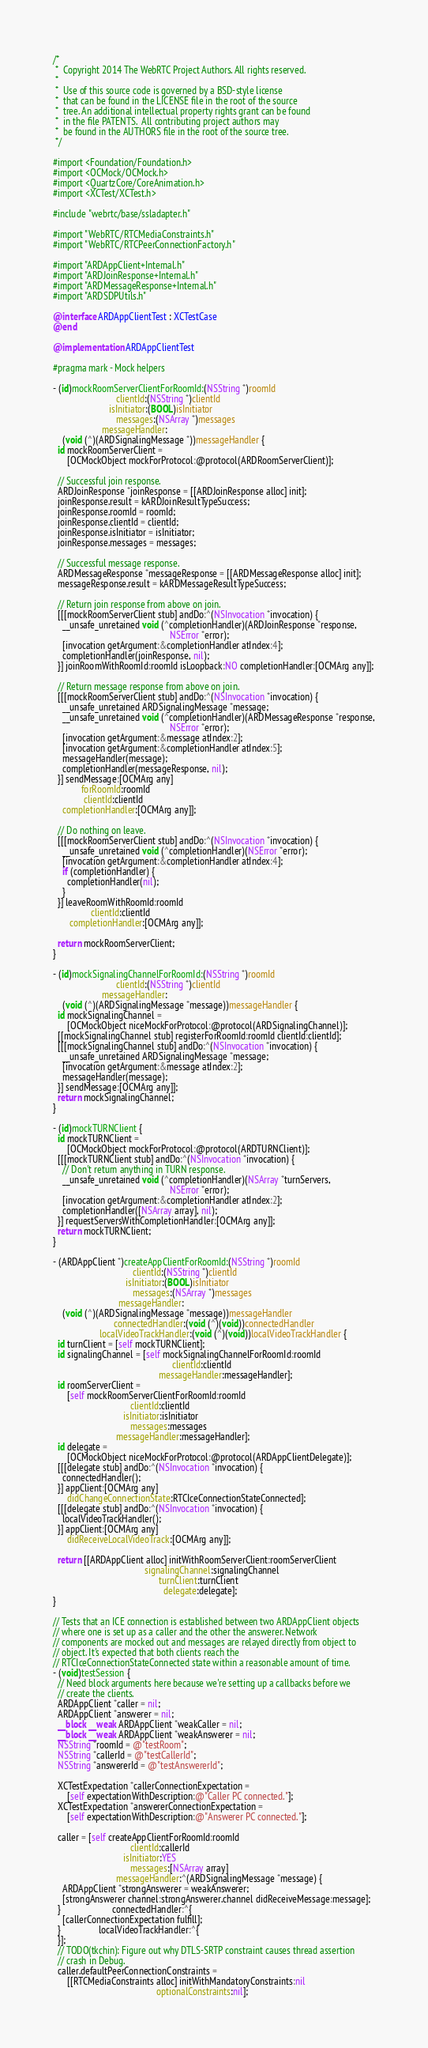Convert code to text. <code><loc_0><loc_0><loc_500><loc_500><_ObjectiveC_>/*
 *  Copyright 2014 The WebRTC Project Authors. All rights reserved.
 *
 *  Use of this source code is governed by a BSD-style license
 *  that can be found in the LICENSE file in the root of the source
 *  tree. An additional intellectual property rights grant can be found
 *  in the file PATENTS.  All contributing project authors may
 *  be found in the AUTHORS file in the root of the source tree.
 */

#import <Foundation/Foundation.h>
#import <OCMock/OCMock.h>
#import <QuartzCore/CoreAnimation.h>
#import <XCTest/XCTest.h>

#include "webrtc/base/ssladapter.h"

#import "WebRTC/RTCMediaConstraints.h"
#import "WebRTC/RTCPeerConnectionFactory.h"

#import "ARDAppClient+Internal.h"
#import "ARDJoinResponse+Internal.h"
#import "ARDMessageResponse+Internal.h"
#import "ARDSDPUtils.h"

@interface ARDAppClientTest : XCTestCase
@end

@implementation ARDAppClientTest

#pragma mark - Mock helpers

- (id)mockRoomServerClientForRoomId:(NSString *)roomId
                           clientId:(NSString *)clientId
                        isInitiator:(BOOL)isInitiator
                           messages:(NSArray *)messages
                     messageHandler:
    (void (^)(ARDSignalingMessage *))messageHandler {
  id mockRoomServerClient =
      [OCMockObject mockForProtocol:@protocol(ARDRoomServerClient)];

  // Successful join response.
  ARDJoinResponse *joinResponse = [[ARDJoinResponse alloc] init];
  joinResponse.result = kARDJoinResultTypeSuccess;
  joinResponse.roomId = roomId;
  joinResponse.clientId = clientId;
  joinResponse.isInitiator = isInitiator;
  joinResponse.messages = messages;

  // Successful message response.
  ARDMessageResponse *messageResponse = [[ARDMessageResponse alloc] init];
  messageResponse.result = kARDMessageResultTypeSuccess;

  // Return join response from above on join.
  [[[mockRoomServerClient stub] andDo:^(NSInvocation *invocation) {
    __unsafe_unretained void (^completionHandler)(ARDJoinResponse *response,
                                                  NSError *error);
    [invocation getArgument:&completionHandler atIndex:4];
    completionHandler(joinResponse, nil);
  }] joinRoomWithRoomId:roomId isLoopback:NO completionHandler:[OCMArg any]];

  // Return message response from above on join.
  [[[mockRoomServerClient stub] andDo:^(NSInvocation *invocation) {
    __unsafe_unretained ARDSignalingMessage *message;
    __unsafe_unretained void (^completionHandler)(ARDMessageResponse *response,
                                                  NSError *error);
    [invocation getArgument:&message atIndex:2];
    [invocation getArgument:&completionHandler atIndex:5];
    messageHandler(message);
    completionHandler(messageResponse, nil);
  }] sendMessage:[OCMArg any]
            forRoomId:roomId
             clientId:clientId
    completionHandler:[OCMArg any]];

  // Do nothing on leave.
  [[[mockRoomServerClient stub] andDo:^(NSInvocation *invocation) {
    __unsafe_unretained void (^completionHandler)(NSError *error);
    [invocation getArgument:&completionHandler atIndex:4];
    if (completionHandler) {
      completionHandler(nil);
    }
  }] leaveRoomWithRoomId:roomId
                clientId:clientId
       completionHandler:[OCMArg any]];

  return mockRoomServerClient;
}

- (id)mockSignalingChannelForRoomId:(NSString *)roomId
                           clientId:(NSString *)clientId
                     messageHandler:
    (void (^)(ARDSignalingMessage *message))messageHandler {
  id mockSignalingChannel =
      [OCMockObject niceMockForProtocol:@protocol(ARDSignalingChannel)];
  [[mockSignalingChannel stub] registerForRoomId:roomId clientId:clientId];
  [[[mockSignalingChannel stub] andDo:^(NSInvocation *invocation) {
    __unsafe_unretained ARDSignalingMessage *message;
    [invocation getArgument:&message atIndex:2];
    messageHandler(message);
  }] sendMessage:[OCMArg any]];
  return mockSignalingChannel;
}

- (id)mockTURNClient {
  id mockTURNClient =
      [OCMockObject mockForProtocol:@protocol(ARDTURNClient)];
  [[[mockTURNClient stub] andDo:^(NSInvocation *invocation) {
    // Don't return anything in TURN response.
    __unsafe_unretained void (^completionHandler)(NSArray *turnServers,
                                                  NSError *error);
    [invocation getArgument:&completionHandler atIndex:2];
    completionHandler([NSArray array], nil);
  }] requestServersWithCompletionHandler:[OCMArg any]];
  return mockTURNClient;
}

- (ARDAppClient *)createAppClientForRoomId:(NSString *)roomId
                                  clientId:(NSString *)clientId
                               isInitiator:(BOOL)isInitiator
                                  messages:(NSArray *)messages
                            messageHandler:
    (void (^)(ARDSignalingMessage *message))messageHandler
                          connectedHandler:(void (^)(void))connectedHandler
                    localVideoTrackHandler:(void (^)(void))localVideoTrackHandler {
  id turnClient = [self mockTURNClient];
  id signalingChannel = [self mockSignalingChannelForRoomId:roomId
                                                   clientId:clientId
                                             messageHandler:messageHandler];
  id roomServerClient =
      [self mockRoomServerClientForRoomId:roomId
                                 clientId:clientId
                              isInitiator:isInitiator
                                 messages:messages
                           messageHandler:messageHandler];
  id delegate =
      [OCMockObject niceMockForProtocol:@protocol(ARDAppClientDelegate)];
  [[[delegate stub] andDo:^(NSInvocation *invocation) {
    connectedHandler();
  }] appClient:[OCMArg any]
      didChangeConnectionState:RTCIceConnectionStateConnected];
  [[[delegate stub] andDo:^(NSInvocation *invocation) {
    localVideoTrackHandler();
  }] appClient:[OCMArg any]
      didReceiveLocalVideoTrack:[OCMArg any]];

  return [[ARDAppClient alloc] initWithRoomServerClient:roomServerClient
                                       signalingChannel:signalingChannel
                                             turnClient:turnClient
                                               delegate:delegate];
}

// Tests that an ICE connection is established between two ARDAppClient objects
// where one is set up as a caller and the other the answerer. Network
// components are mocked out and messages are relayed directly from object to
// object. It's expected that both clients reach the
// RTCIceConnectionStateConnected state within a reasonable amount of time.
- (void)testSession {
  // Need block arguments here because we're setting up a callbacks before we
  // create the clients.
  ARDAppClient *caller = nil;
  ARDAppClient *answerer = nil;
  __block __weak ARDAppClient *weakCaller = nil;
  __block __weak ARDAppClient *weakAnswerer = nil;
  NSString *roomId = @"testRoom";
  NSString *callerId = @"testCallerId";
  NSString *answererId = @"testAnswererId";

  XCTestExpectation *callerConnectionExpectation =
      [self expectationWithDescription:@"Caller PC connected."];
  XCTestExpectation *answererConnectionExpectation =
      [self expectationWithDescription:@"Answerer PC connected."];

  caller = [self createAppClientForRoomId:roomId
                                 clientId:callerId
                              isInitiator:YES
                                 messages:[NSArray array]
                           messageHandler:^(ARDSignalingMessage *message) {
    ARDAppClient *strongAnswerer = weakAnswerer;
    [strongAnswerer channel:strongAnswerer.channel didReceiveMessage:message];
  }                      connectedHandler:^{
    [callerConnectionExpectation fulfill];
  }                localVideoTrackHandler:^{
  }];
  // TODO(tkchin): Figure out why DTLS-SRTP constraint causes thread assertion
  // crash in Debug.
  caller.defaultPeerConnectionConstraints =
      [[RTCMediaConstraints alloc] initWithMandatoryConstraints:nil
                                            optionalConstraints:nil];</code> 